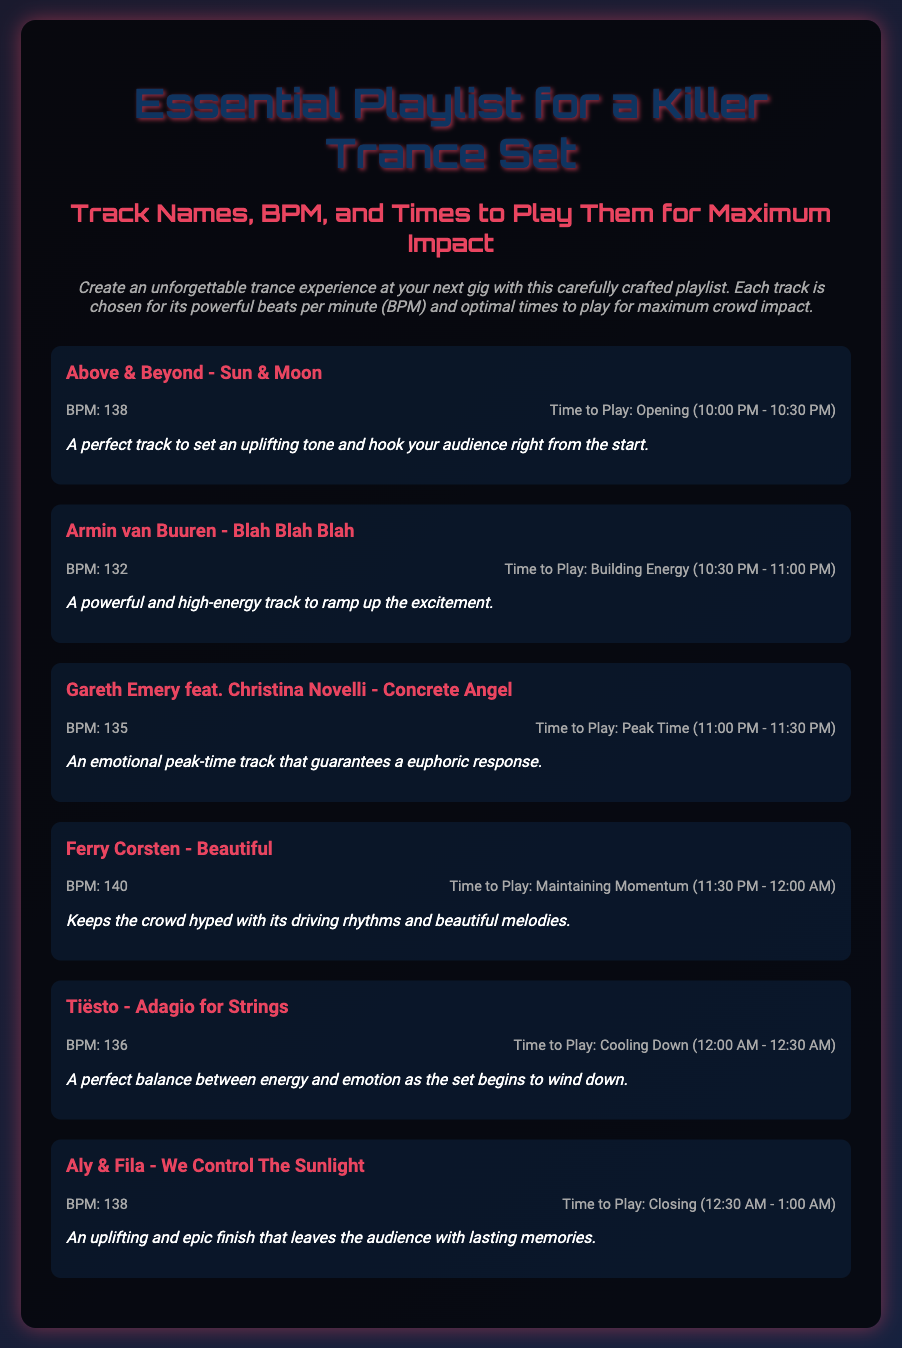What is the title of the playlist? The title of the playlist is stated prominently at the top of the document.
Answer: Essential Playlist for a Killer Trance Set Which track has the highest BPM? The highest BPM listed among the tracks is found in the track details.
Answer: 140 What time frame is "Sun & Moon" recommended to be played? The time to play "Sun & Moon" is provided in the track information section.
Answer: Opening (10:00 PM - 10:30 PM) Which artist is featured in "Concrete Angel"? The document specifically mentions the collaboration in the track details.
Answer: Gareth Emery feat. Christina Novelli What is the BPM of "Adagio for Strings"? The BPM for "Adagio for Strings" is explicitly mentioned in the track information.
Answer: 136 During which time is "We Control The Sunlight" suggested to be played? The time to play "We Control The Sunlight" is indicated in the track section.
Answer: Closing (12:30 AM - 1:00 AM) What is a common theme described for the track "Beautiful"? The description provides a thematic overview of the track's effect on the audience.
Answer: Driving rhythms and beautiful melodies Which track is suggested for the peak time? The track recommended for peak time is mentioned along with its playtime in the document.
Answer: Concrete Angel 